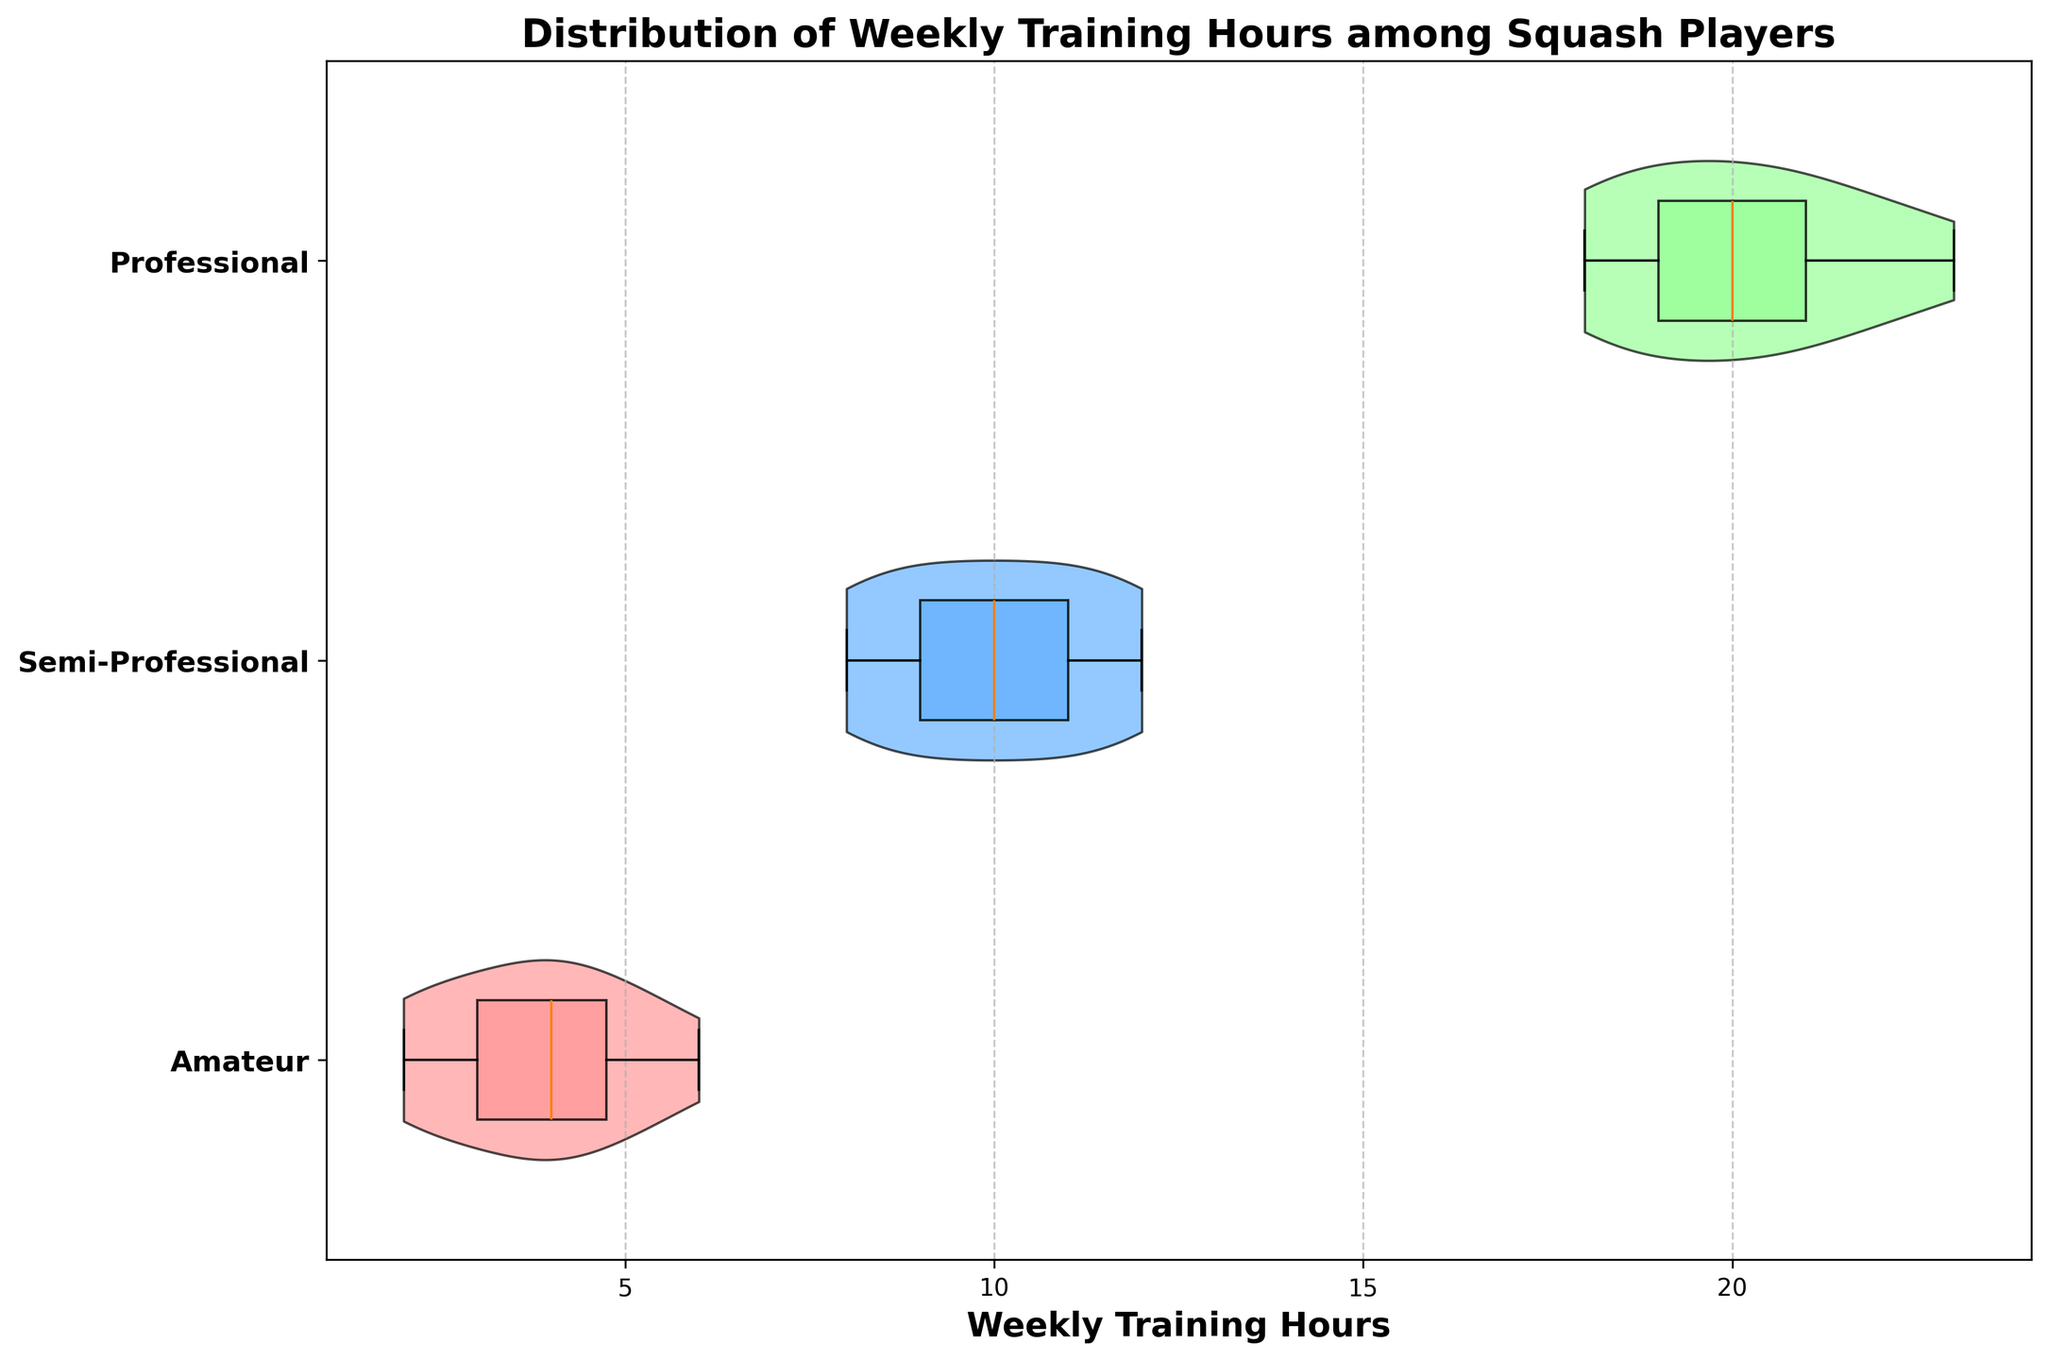What is the title of the figure? The title of a figure is typically found at the top part of the plot. In this case, it reads "Distribution of Weekly Training Hours among Squash Players".
Answer: Distribution of Weekly Training Hours among Squash Players What are the labels on the y-axis? The y-axis labels are usually on the left side of the plot. Here, they represent different player types: “Amateur”, “Semi-Professional”, and “Professional”.
Answer: Amateur, Semi-Professional, Professional What is the range of training hours for professional players? To find the range, identify the minimum and maximum values in the professional player's distribution. The horizontal spread of the violin plot for professionals extends from 18 to 23 hours.
Answer: 18 to 23 hours Which group has the widest distribution of training hours? The width of the violin plot at various points shows the distribution spread. By comparing all groups, professional players have the widest horizontal spread, indicating the largest range.
Answer: Professional What is the median training hours for semi-professional players? The boxplot within the violin plot shows the median as the central horizontal line inside the box. For semi-professionals, it aligns at 10 hours.
Answer: 10 hours How do the training hours of amateur players compare to semi-professional players? Comparing the violins and boxplots, amateur players' training hours range from 2 to 6, while semi-professionals range from 8 to 12. Semi-professionals generally train significantly more.
Answer: Semi-professionals train more than amateurs What is the interquartile range (IQR) for professional players? The IQR is the difference between the third quartile and the first quartile on the boxplot. For professionals, the box ranges roughly from 19 to 21 hours, making the IQR 21 - 19 = 2 hours.
Answer: 2 hours Which player type has the most consistent training hours? Consistency can be inferred from a narrow violin plot. Amateur players show the narrowest spread, indicating the most consistent training hours compared to semi-professionals and professionals.
Answer: Amateur Is there any overlap in training hours among the different player types? Overlap would be indicated by intersecting horizontal ranges of the violin plots. The ranges of amateurs (2-6), semi-professionals (8-12), and professionals (18-23) do not overlap.
Answer: No What does the color of each violin plot represent? Colors differentiate between player types. The violins are colored pink for amateurs, blue for semi-professionals, and green for professionals. Each color makes it easier to distinguish between player distributions.
Answer: Different player types: amateurs (pink), semi-professionals (blue), professionals (green) 